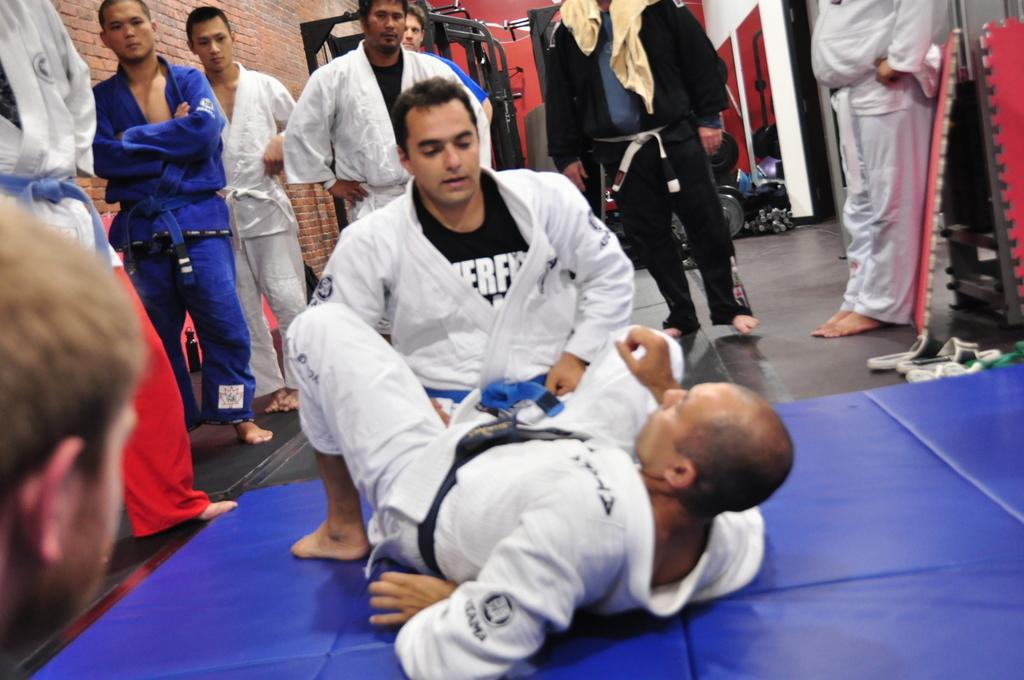What are the two men in the image doing? The two men are performing karate. Are there any other people present in the image? Yes, a group of people are standing nearby. What are the people wearing? The people are wearing karate costumes. What can be seen in the background of the image? There is some equipment visible in the background. What is the value of the zephyr in the image? There is no zephyr present in the image, so it is not possible to determine its value. 